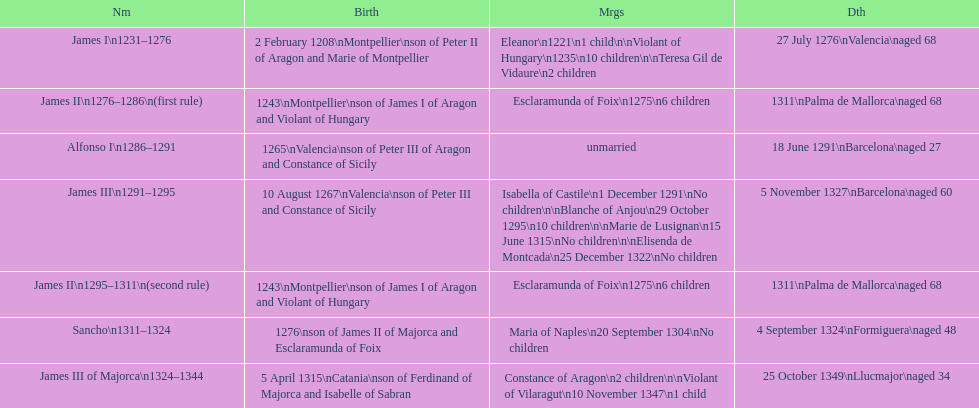Was james iii or sancho born in the year 1276? Sancho. 